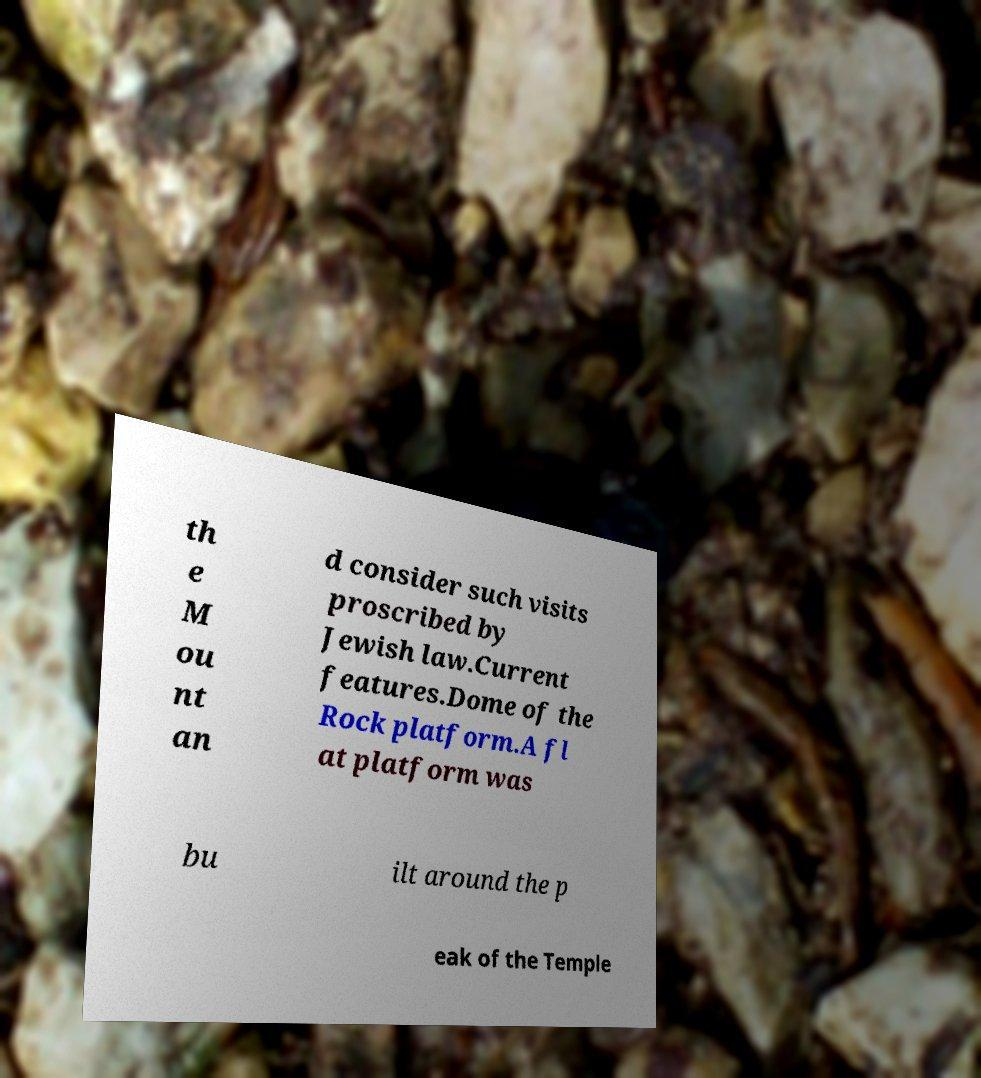For documentation purposes, I need the text within this image transcribed. Could you provide that? th e M ou nt an d consider such visits proscribed by Jewish law.Current features.Dome of the Rock platform.A fl at platform was bu ilt around the p eak of the Temple 